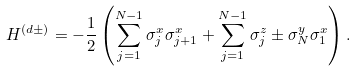Convert formula to latex. <formula><loc_0><loc_0><loc_500><loc_500>H ^ { ( d \pm ) } = - \frac { 1 } { 2 } \left ( \sum _ { j = 1 } ^ { N - 1 } \sigma _ { j } ^ { x } \sigma _ { j + 1 } ^ { x } + \sum _ { j = 1 } ^ { N - 1 } \sigma _ { j } ^ { z } \pm \sigma _ { N } ^ { y } \sigma _ { 1 } ^ { x } \right ) .</formula> 